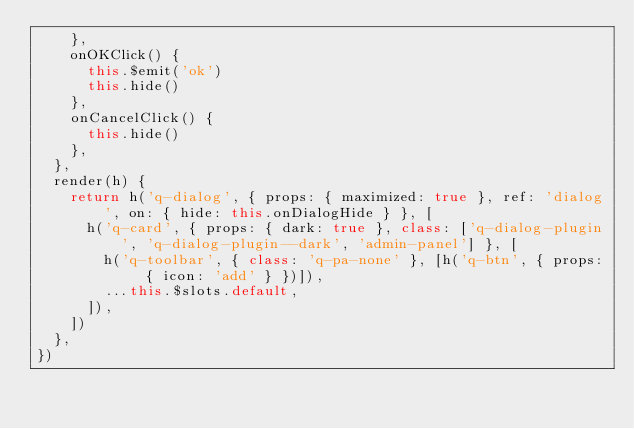Convert code to text. <code><loc_0><loc_0><loc_500><loc_500><_JavaScript_>    },
    onOKClick() {
      this.$emit('ok')
      this.hide()
    },
    onCancelClick() {
      this.hide()
    },
  },
  render(h) {
    return h('q-dialog', { props: { maximized: true }, ref: 'dialog', on: { hide: this.onDialogHide } }, [
      h('q-card', { props: { dark: true }, class: ['q-dialog-plugin', 'q-dialog-plugin--dark', 'admin-panel'] }, [
        h('q-toolbar', { class: 'q-pa-none' }, [h('q-btn', { props: { icon: 'add' } })]),
        ...this.$slots.default,
      ]),
    ])
  },
})
</code> 